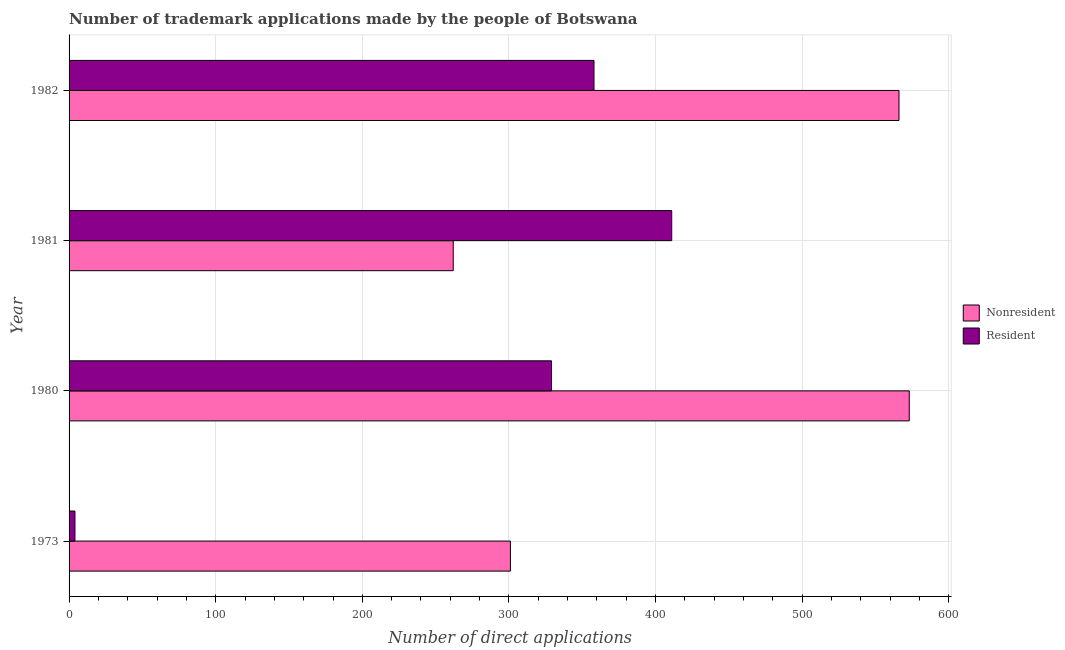How many groups of bars are there?
Your answer should be very brief. 4. Are the number of bars on each tick of the Y-axis equal?
Make the answer very short. Yes. How many bars are there on the 1st tick from the top?
Your answer should be very brief. 2. In how many cases, is the number of bars for a given year not equal to the number of legend labels?
Ensure brevity in your answer.  0. What is the number of trademark applications made by non residents in 1982?
Your answer should be very brief. 566. Across all years, what is the maximum number of trademark applications made by residents?
Offer a terse response. 411. Across all years, what is the minimum number of trademark applications made by residents?
Provide a succinct answer. 4. What is the total number of trademark applications made by residents in the graph?
Offer a very short reply. 1102. What is the difference between the number of trademark applications made by non residents in 1973 and that in 1981?
Your answer should be compact. 39. What is the difference between the number of trademark applications made by residents in 1980 and the number of trademark applications made by non residents in 1982?
Provide a short and direct response. -237. What is the average number of trademark applications made by non residents per year?
Keep it short and to the point. 425.5. In the year 1981, what is the difference between the number of trademark applications made by residents and number of trademark applications made by non residents?
Offer a terse response. 149. In how many years, is the number of trademark applications made by non residents greater than 420 ?
Offer a very short reply. 2. What is the ratio of the number of trademark applications made by non residents in 1973 to that in 1980?
Make the answer very short. 0.53. What is the difference between the highest and the lowest number of trademark applications made by non residents?
Offer a terse response. 311. In how many years, is the number of trademark applications made by non residents greater than the average number of trademark applications made by non residents taken over all years?
Provide a short and direct response. 2. Is the sum of the number of trademark applications made by non residents in 1981 and 1982 greater than the maximum number of trademark applications made by residents across all years?
Provide a short and direct response. Yes. What does the 2nd bar from the top in 1982 represents?
Give a very brief answer. Nonresident. What does the 2nd bar from the bottom in 1982 represents?
Make the answer very short. Resident. Are all the bars in the graph horizontal?
Your answer should be very brief. Yes. How many years are there in the graph?
Ensure brevity in your answer.  4. Does the graph contain any zero values?
Make the answer very short. No. How many legend labels are there?
Your answer should be compact. 2. What is the title of the graph?
Provide a short and direct response. Number of trademark applications made by the people of Botswana. Does "Import" appear as one of the legend labels in the graph?
Your response must be concise. No. What is the label or title of the X-axis?
Your answer should be very brief. Number of direct applications. What is the label or title of the Y-axis?
Make the answer very short. Year. What is the Number of direct applications of Nonresident in 1973?
Your answer should be very brief. 301. What is the Number of direct applications in Nonresident in 1980?
Your answer should be very brief. 573. What is the Number of direct applications in Resident in 1980?
Offer a very short reply. 329. What is the Number of direct applications of Nonresident in 1981?
Make the answer very short. 262. What is the Number of direct applications of Resident in 1981?
Your answer should be compact. 411. What is the Number of direct applications in Nonresident in 1982?
Give a very brief answer. 566. What is the Number of direct applications of Resident in 1982?
Provide a short and direct response. 358. Across all years, what is the maximum Number of direct applications of Nonresident?
Offer a terse response. 573. Across all years, what is the maximum Number of direct applications of Resident?
Your response must be concise. 411. Across all years, what is the minimum Number of direct applications of Nonresident?
Keep it short and to the point. 262. Across all years, what is the minimum Number of direct applications of Resident?
Make the answer very short. 4. What is the total Number of direct applications of Nonresident in the graph?
Offer a very short reply. 1702. What is the total Number of direct applications in Resident in the graph?
Offer a very short reply. 1102. What is the difference between the Number of direct applications of Nonresident in 1973 and that in 1980?
Keep it short and to the point. -272. What is the difference between the Number of direct applications in Resident in 1973 and that in 1980?
Your answer should be very brief. -325. What is the difference between the Number of direct applications in Resident in 1973 and that in 1981?
Ensure brevity in your answer.  -407. What is the difference between the Number of direct applications of Nonresident in 1973 and that in 1982?
Your answer should be compact. -265. What is the difference between the Number of direct applications in Resident in 1973 and that in 1982?
Provide a succinct answer. -354. What is the difference between the Number of direct applications of Nonresident in 1980 and that in 1981?
Give a very brief answer. 311. What is the difference between the Number of direct applications in Resident in 1980 and that in 1981?
Offer a terse response. -82. What is the difference between the Number of direct applications in Nonresident in 1980 and that in 1982?
Make the answer very short. 7. What is the difference between the Number of direct applications of Resident in 1980 and that in 1982?
Give a very brief answer. -29. What is the difference between the Number of direct applications of Nonresident in 1981 and that in 1982?
Ensure brevity in your answer.  -304. What is the difference between the Number of direct applications of Resident in 1981 and that in 1982?
Your answer should be compact. 53. What is the difference between the Number of direct applications in Nonresident in 1973 and the Number of direct applications in Resident in 1981?
Your answer should be compact. -110. What is the difference between the Number of direct applications in Nonresident in 1973 and the Number of direct applications in Resident in 1982?
Your answer should be compact. -57. What is the difference between the Number of direct applications of Nonresident in 1980 and the Number of direct applications of Resident in 1981?
Give a very brief answer. 162. What is the difference between the Number of direct applications of Nonresident in 1980 and the Number of direct applications of Resident in 1982?
Offer a very short reply. 215. What is the difference between the Number of direct applications of Nonresident in 1981 and the Number of direct applications of Resident in 1982?
Your response must be concise. -96. What is the average Number of direct applications in Nonresident per year?
Offer a terse response. 425.5. What is the average Number of direct applications in Resident per year?
Your response must be concise. 275.5. In the year 1973, what is the difference between the Number of direct applications of Nonresident and Number of direct applications of Resident?
Offer a very short reply. 297. In the year 1980, what is the difference between the Number of direct applications in Nonresident and Number of direct applications in Resident?
Offer a very short reply. 244. In the year 1981, what is the difference between the Number of direct applications of Nonresident and Number of direct applications of Resident?
Your response must be concise. -149. In the year 1982, what is the difference between the Number of direct applications in Nonresident and Number of direct applications in Resident?
Offer a terse response. 208. What is the ratio of the Number of direct applications of Nonresident in 1973 to that in 1980?
Your response must be concise. 0.53. What is the ratio of the Number of direct applications in Resident in 1973 to that in 1980?
Offer a terse response. 0.01. What is the ratio of the Number of direct applications of Nonresident in 1973 to that in 1981?
Your answer should be very brief. 1.15. What is the ratio of the Number of direct applications of Resident in 1973 to that in 1981?
Keep it short and to the point. 0.01. What is the ratio of the Number of direct applications in Nonresident in 1973 to that in 1982?
Make the answer very short. 0.53. What is the ratio of the Number of direct applications in Resident in 1973 to that in 1982?
Your response must be concise. 0.01. What is the ratio of the Number of direct applications in Nonresident in 1980 to that in 1981?
Provide a short and direct response. 2.19. What is the ratio of the Number of direct applications of Resident in 1980 to that in 1981?
Offer a terse response. 0.8. What is the ratio of the Number of direct applications in Nonresident in 1980 to that in 1982?
Your answer should be compact. 1.01. What is the ratio of the Number of direct applications in Resident in 1980 to that in 1982?
Give a very brief answer. 0.92. What is the ratio of the Number of direct applications of Nonresident in 1981 to that in 1982?
Your answer should be very brief. 0.46. What is the ratio of the Number of direct applications of Resident in 1981 to that in 1982?
Your response must be concise. 1.15. What is the difference between the highest and the second highest Number of direct applications of Nonresident?
Provide a short and direct response. 7. What is the difference between the highest and the lowest Number of direct applications of Nonresident?
Keep it short and to the point. 311. What is the difference between the highest and the lowest Number of direct applications in Resident?
Ensure brevity in your answer.  407. 